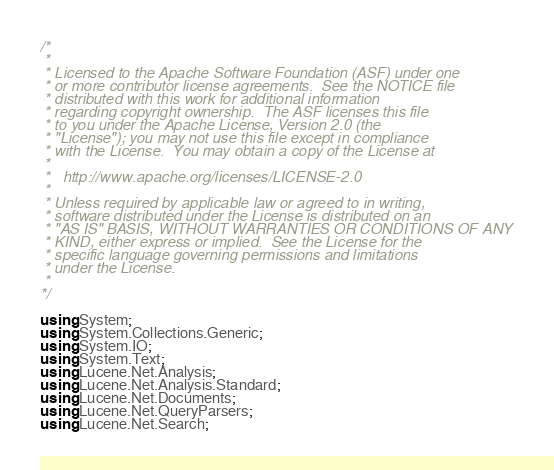Convert code to text. <code><loc_0><loc_0><loc_500><loc_500><_C#_>/*
 *
 * Licensed to the Apache Software Foundation (ASF) under one
 * or more contributor license agreements.  See the NOTICE file
 * distributed with this work for additional information
 * regarding copyright ownership.  The ASF licenses this file
 * to you under the Apache License, Version 2.0 (the
 * "License"); you may not use this file except in compliance
 * with the License.  You may obtain a copy of the License at
 *
 *   http://www.apache.org/licenses/LICENSE-2.0
 *
 * Unless required by applicable law or agreed to in writing,
 * software distributed under the License is distributed on an
 * "AS IS" BASIS, WITHOUT WARRANTIES OR CONDITIONS OF ANY
 * KIND, either express or implied.  See the License for the
 * specific language governing permissions and limitations
 * under the License.
 *
*/

using System;
using System.Collections.Generic;
using System.IO;
using System.Text;
using Lucene.Net.Analysis;
using Lucene.Net.Analysis.Standard;
using Lucene.Net.Documents;
using Lucene.Net.QueryParsers;
using Lucene.Net.Search;</code> 